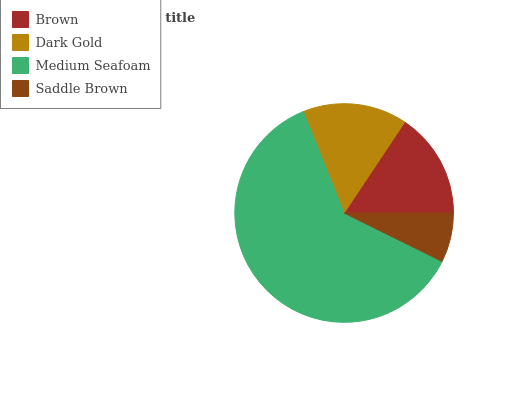Is Saddle Brown the minimum?
Answer yes or no. Yes. Is Medium Seafoam the maximum?
Answer yes or no. Yes. Is Dark Gold the minimum?
Answer yes or no. No. Is Dark Gold the maximum?
Answer yes or no. No. Is Brown greater than Dark Gold?
Answer yes or no. Yes. Is Dark Gold less than Brown?
Answer yes or no. Yes. Is Dark Gold greater than Brown?
Answer yes or no. No. Is Brown less than Dark Gold?
Answer yes or no. No. Is Brown the high median?
Answer yes or no. Yes. Is Dark Gold the low median?
Answer yes or no. Yes. Is Saddle Brown the high median?
Answer yes or no. No. Is Saddle Brown the low median?
Answer yes or no. No. 